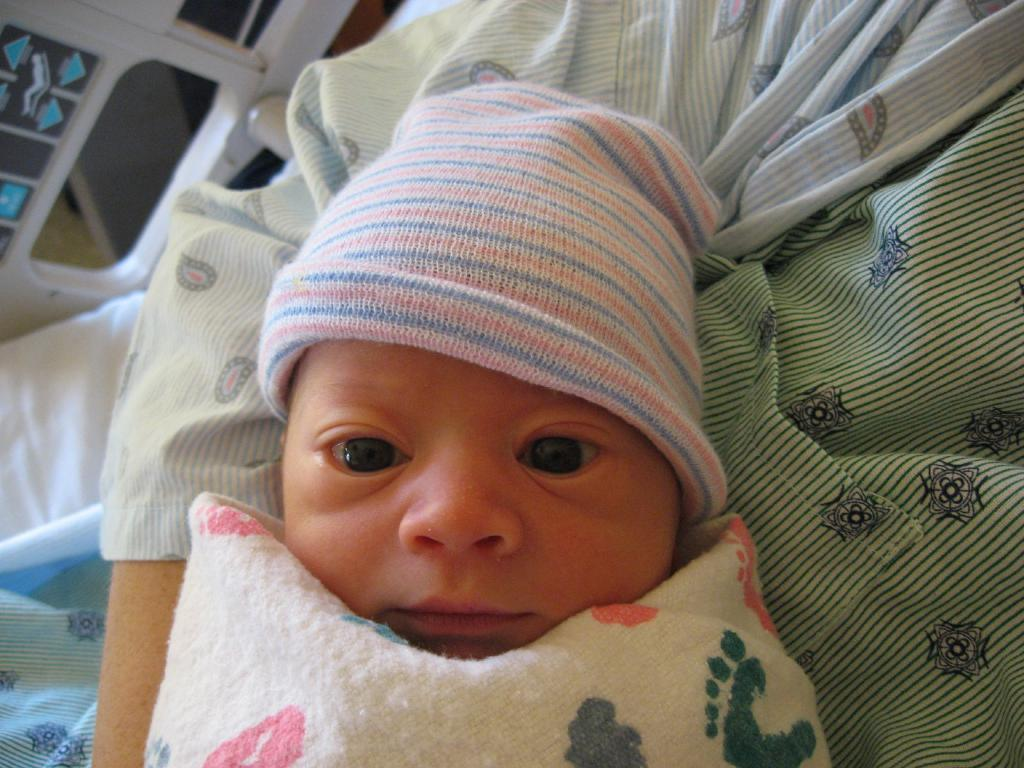What is the person in the image doing? The person in the image is carrying a child. What is the child wearing on their head? The child is wearing a cap. How is the child dressed in the image? The child is covered with clothes. What can be seen in the background of the image? There are objects visible in the background of the image. Is the queen present in the image? There is no mention of a queen in the image, so we cannot confirm her presence. 